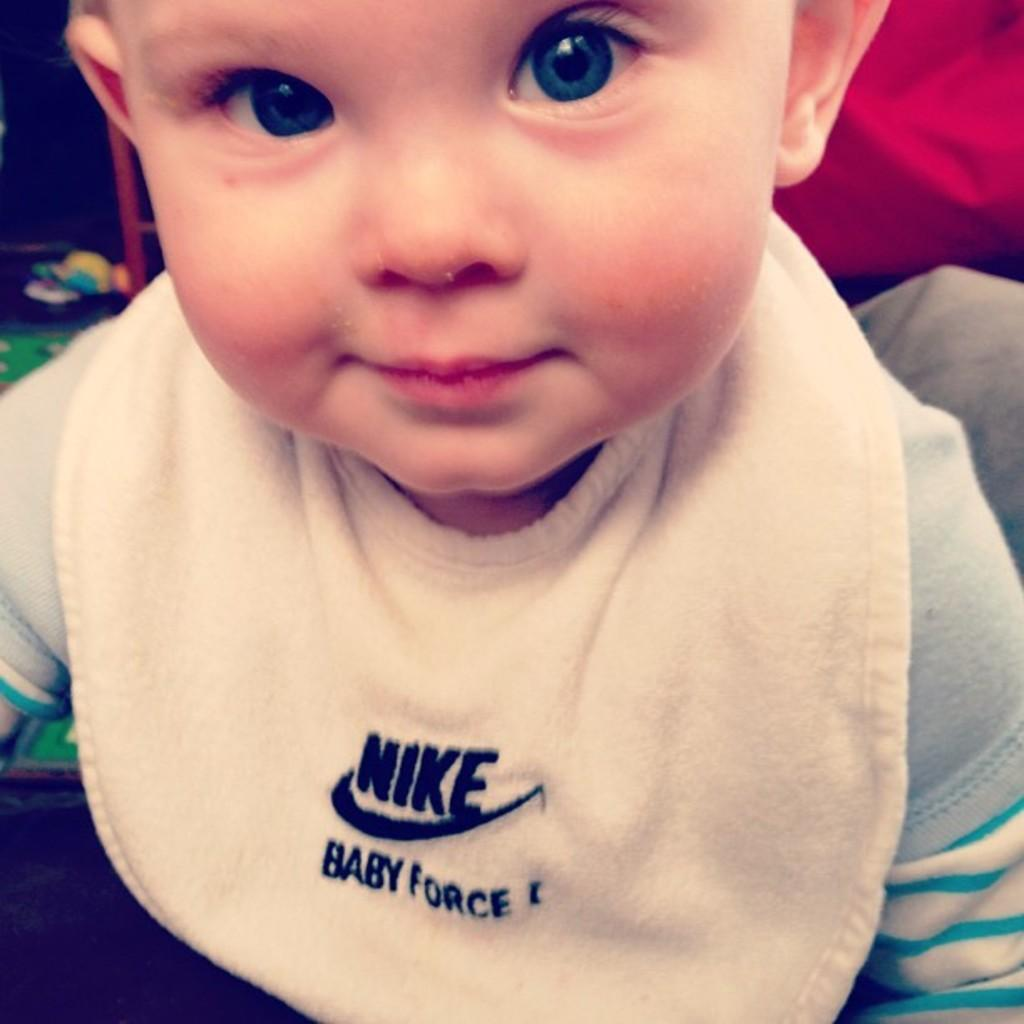What is the main subject of the image? There is a child in the image. Can you describe the child's clothing? The child is wearing a white, ash, and blue dress. What colors can be seen in the background of the image? There is a red and ash-colored cloth in the background. What is located to the left of the image? The provided facts do not specify what objects are to the left of the image. How many socks is the child wearing in the image? The provided facts do not mention any socks, so we cannot determine how many the child is wearing. What color is the crayon that the child is using in the image? There is no crayon present in the image. 